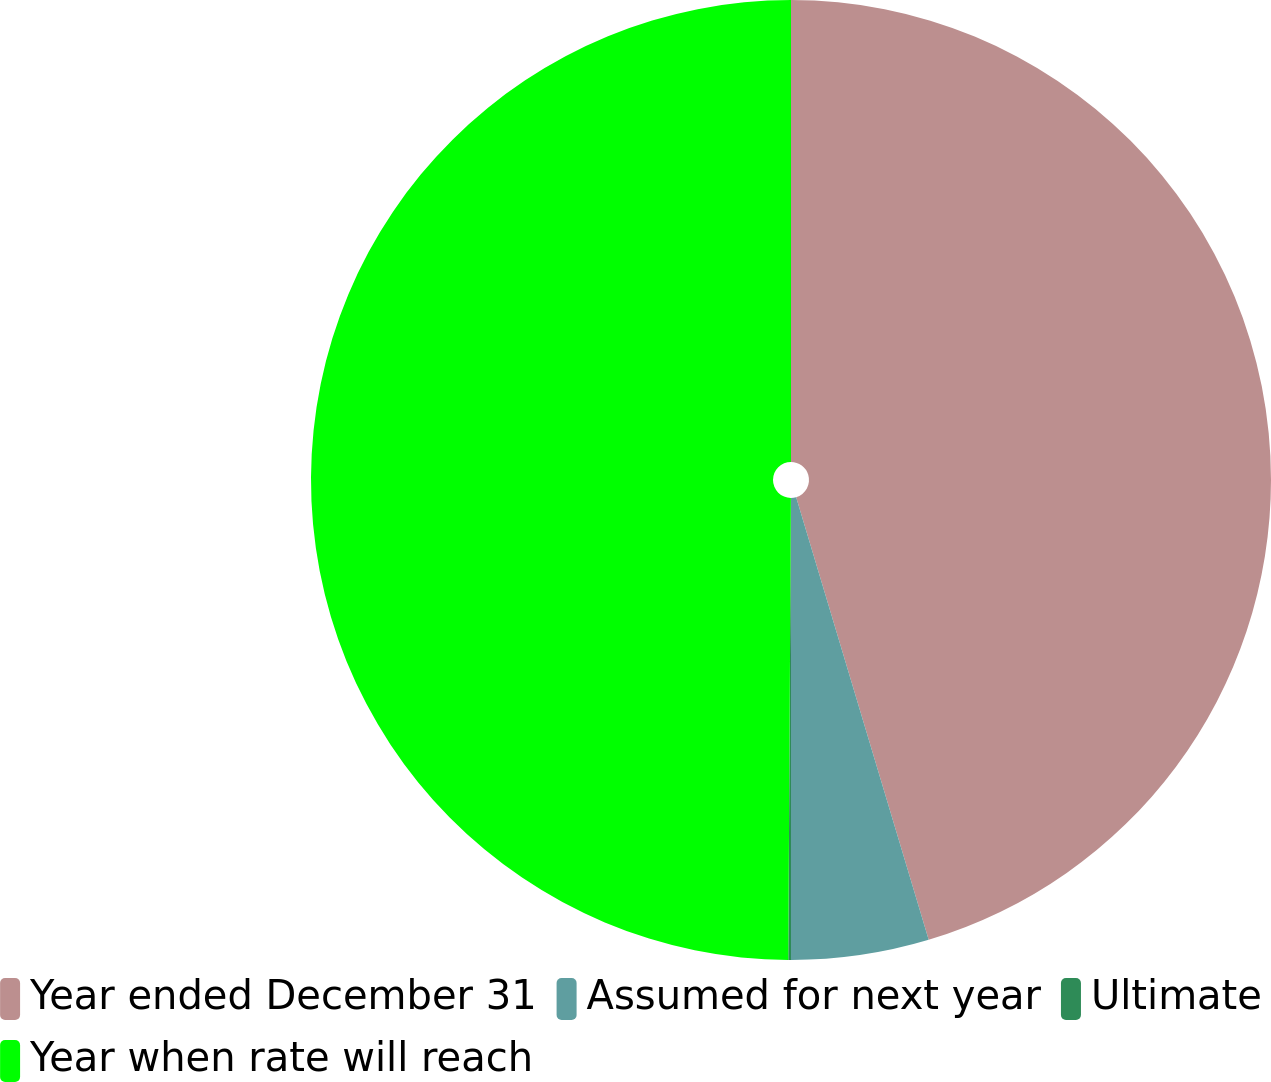<chart> <loc_0><loc_0><loc_500><loc_500><pie_chart><fcel>Year ended December 31<fcel>Assumed for next year<fcel>Ultimate<fcel>Year when rate will reach<nl><fcel>45.37%<fcel>4.63%<fcel>0.09%<fcel>49.91%<nl></chart> 